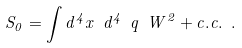<formula> <loc_0><loc_0><loc_500><loc_500>S _ { 0 } = \int d ^ { 4 } x \ d ^ { 4 } \ q \ W ^ { 2 } + c . c . \ .</formula> 